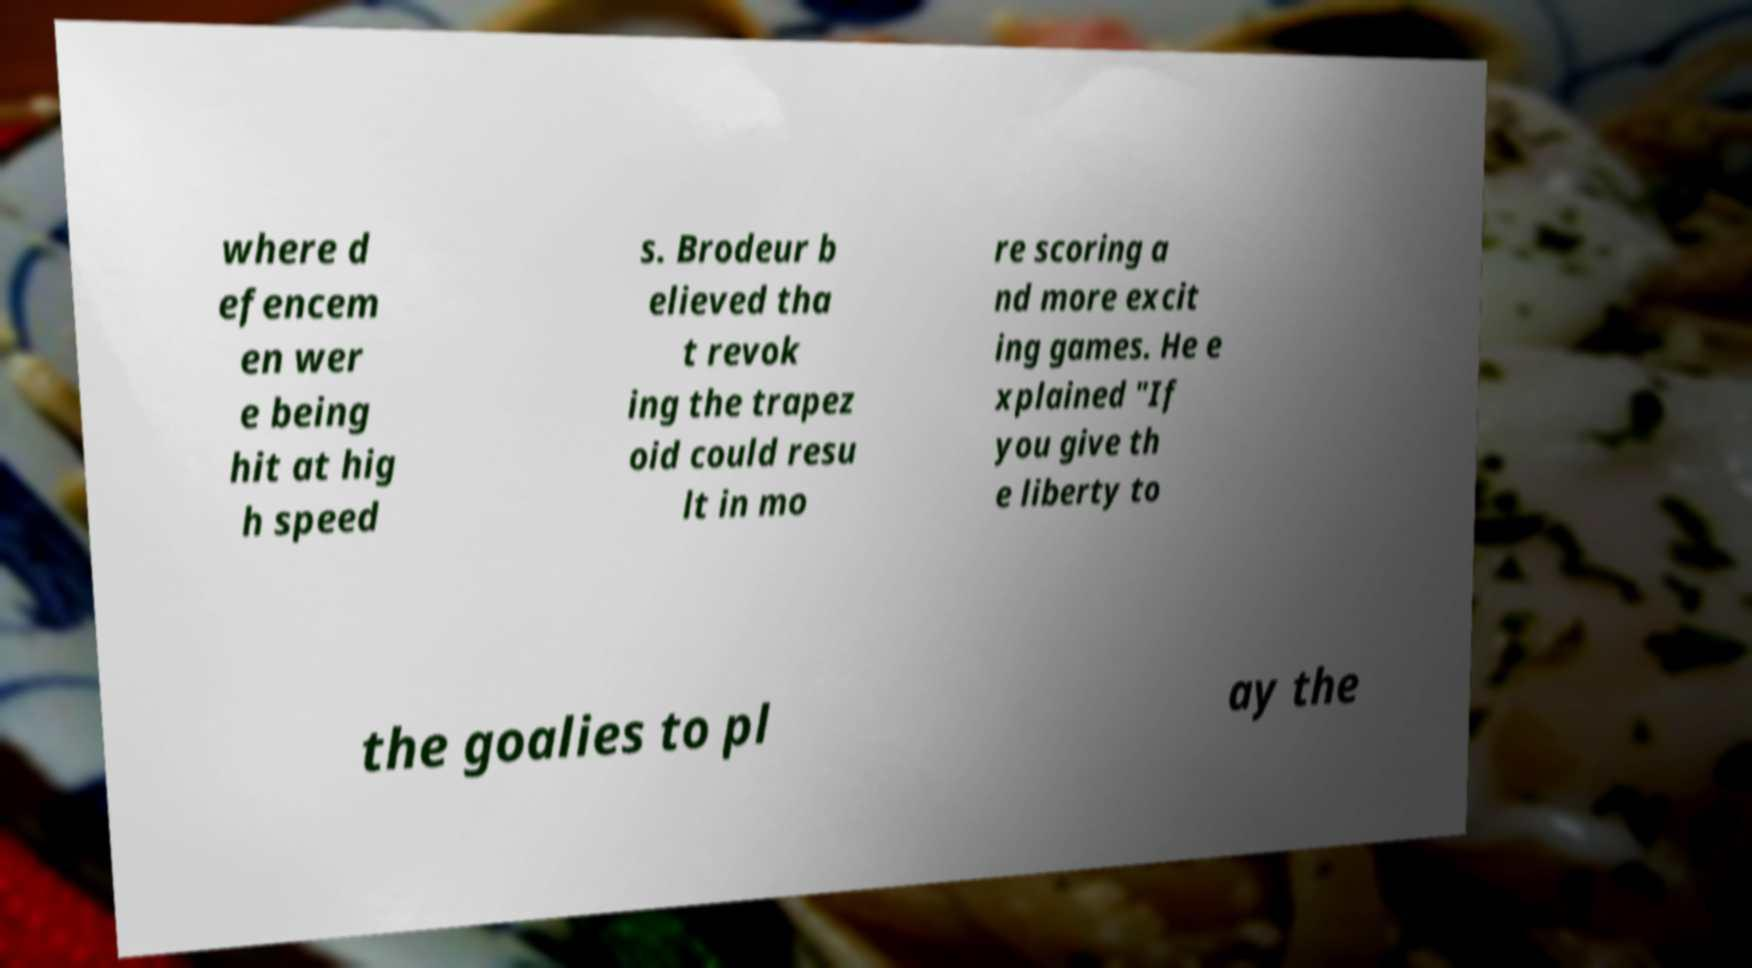Please identify and transcribe the text found in this image. where d efencem en wer e being hit at hig h speed s. Brodeur b elieved tha t revok ing the trapez oid could resu lt in mo re scoring a nd more excit ing games. He e xplained "If you give th e liberty to the goalies to pl ay the 